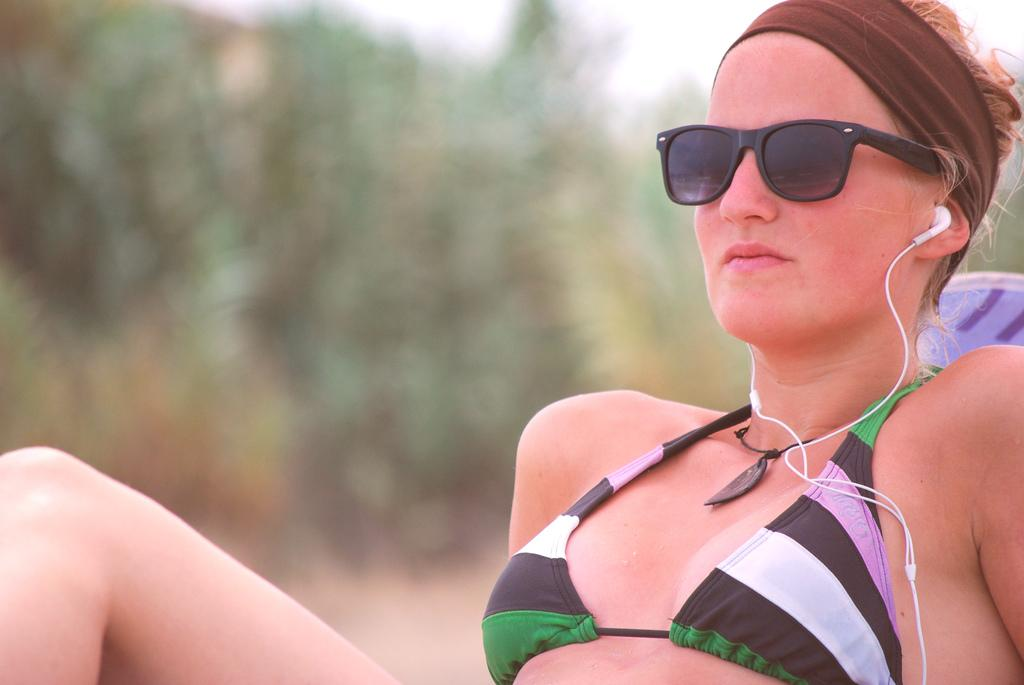Who is the main subject in the image? There is a woman in the image. What is the woman wearing on her face? The woman is wearing a goggle. What else is the woman wearing? The woman is also wearing a headphone. Can you describe the background of the image? The background of the image is blurry. What type of weather is depicted in the image? There is no indication of weather in the image, as it focuses on the woman and her accessories. 